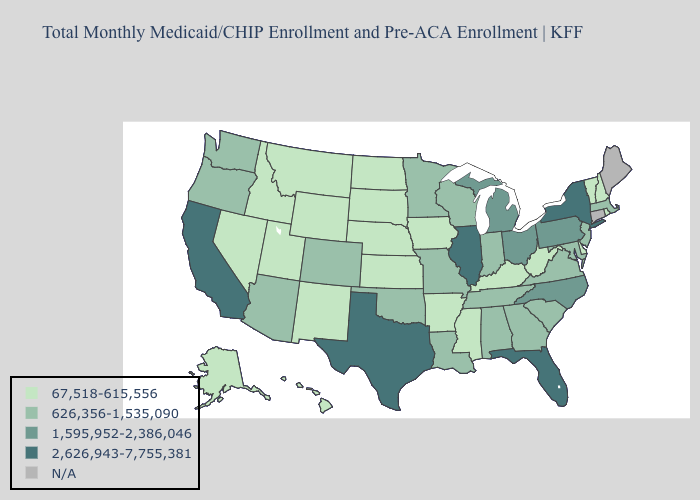Name the states that have a value in the range 1,595,952-2,386,046?
Answer briefly. Michigan, North Carolina, Ohio, Pennsylvania. What is the lowest value in states that border Vermont?
Short answer required. 67,518-615,556. What is the highest value in states that border Oregon?
Concise answer only. 2,626,943-7,755,381. Among the states that border Virginia , does North Carolina have the highest value?
Be succinct. Yes. Is the legend a continuous bar?
Short answer required. No. Which states hav the highest value in the South?
Concise answer only. Florida, Texas. What is the value of Connecticut?
Answer briefly. N/A. What is the value of New Hampshire?
Short answer required. 67,518-615,556. How many symbols are there in the legend?
Quick response, please. 5. What is the value of New York?
Quick response, please. 2,626,943-7,755,381. Does Illinois have the highest value in the MidWest?
Concise answer only. Yes. Does New York have the highest value in the Northeast?
Concise answer only. Yes. Name the states that have a value in the range 67,518-615,556?
Write a very short answer. Alaska, Arkansas, Delaware, Hawaii, Idaho, Iowa, Kansas, Kentucky, Mississippi, Montana, Nebraska, Nevada, New Hampshire, New Mexico, North Dakota, Rhode Island, South Dakota, Utah, Vermont, West Virginia, Wyoming. Name the states that have a value in the range 626,356-1,535,090?
Write a very short answer. Alabama, Arizona, Colorado, Georgia, Indiana, Louisiana, Maryland, Massachusetts, Minnesota, Missouri, New Jersey, Oklahoma, Oregon, South Carolina, Tennessee, Virginia, Washington, Wisconsin. 